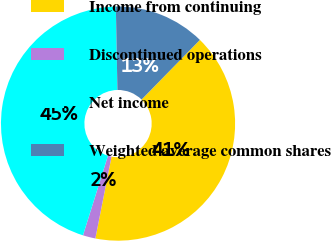<chart> <loc_0><loc_0><loc_500><loc_500><pie_chart><fcel>Income from continuing<fcel>Discontinued operations<fcel>Net income<fcel>Weighted average common shares<nl><fcel>40.78%<fcel>1.74%<fcel>44.86%<fcel>12.62%<nl></chart> 